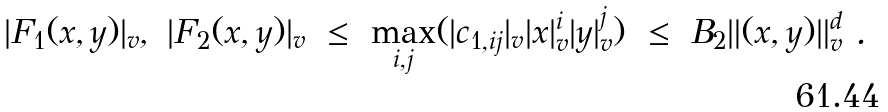<formula> <loc_0><loc_0><loc_500><loc_500>| F _ { 1 } ( x , y ) | _ { v } , \ | F _ { 2 } ( x , y ) | _ { v } \ \leq \ \max _ { i , j } ( | c _ { 1 , i j } | _ { v } | x | _ { v } ^ { i } | y | _ { v } ^ { j } ) \ \leq \ B _ { 2 } \| ( x , y ) \| _ { v } ^ { d } \ .</formula> 